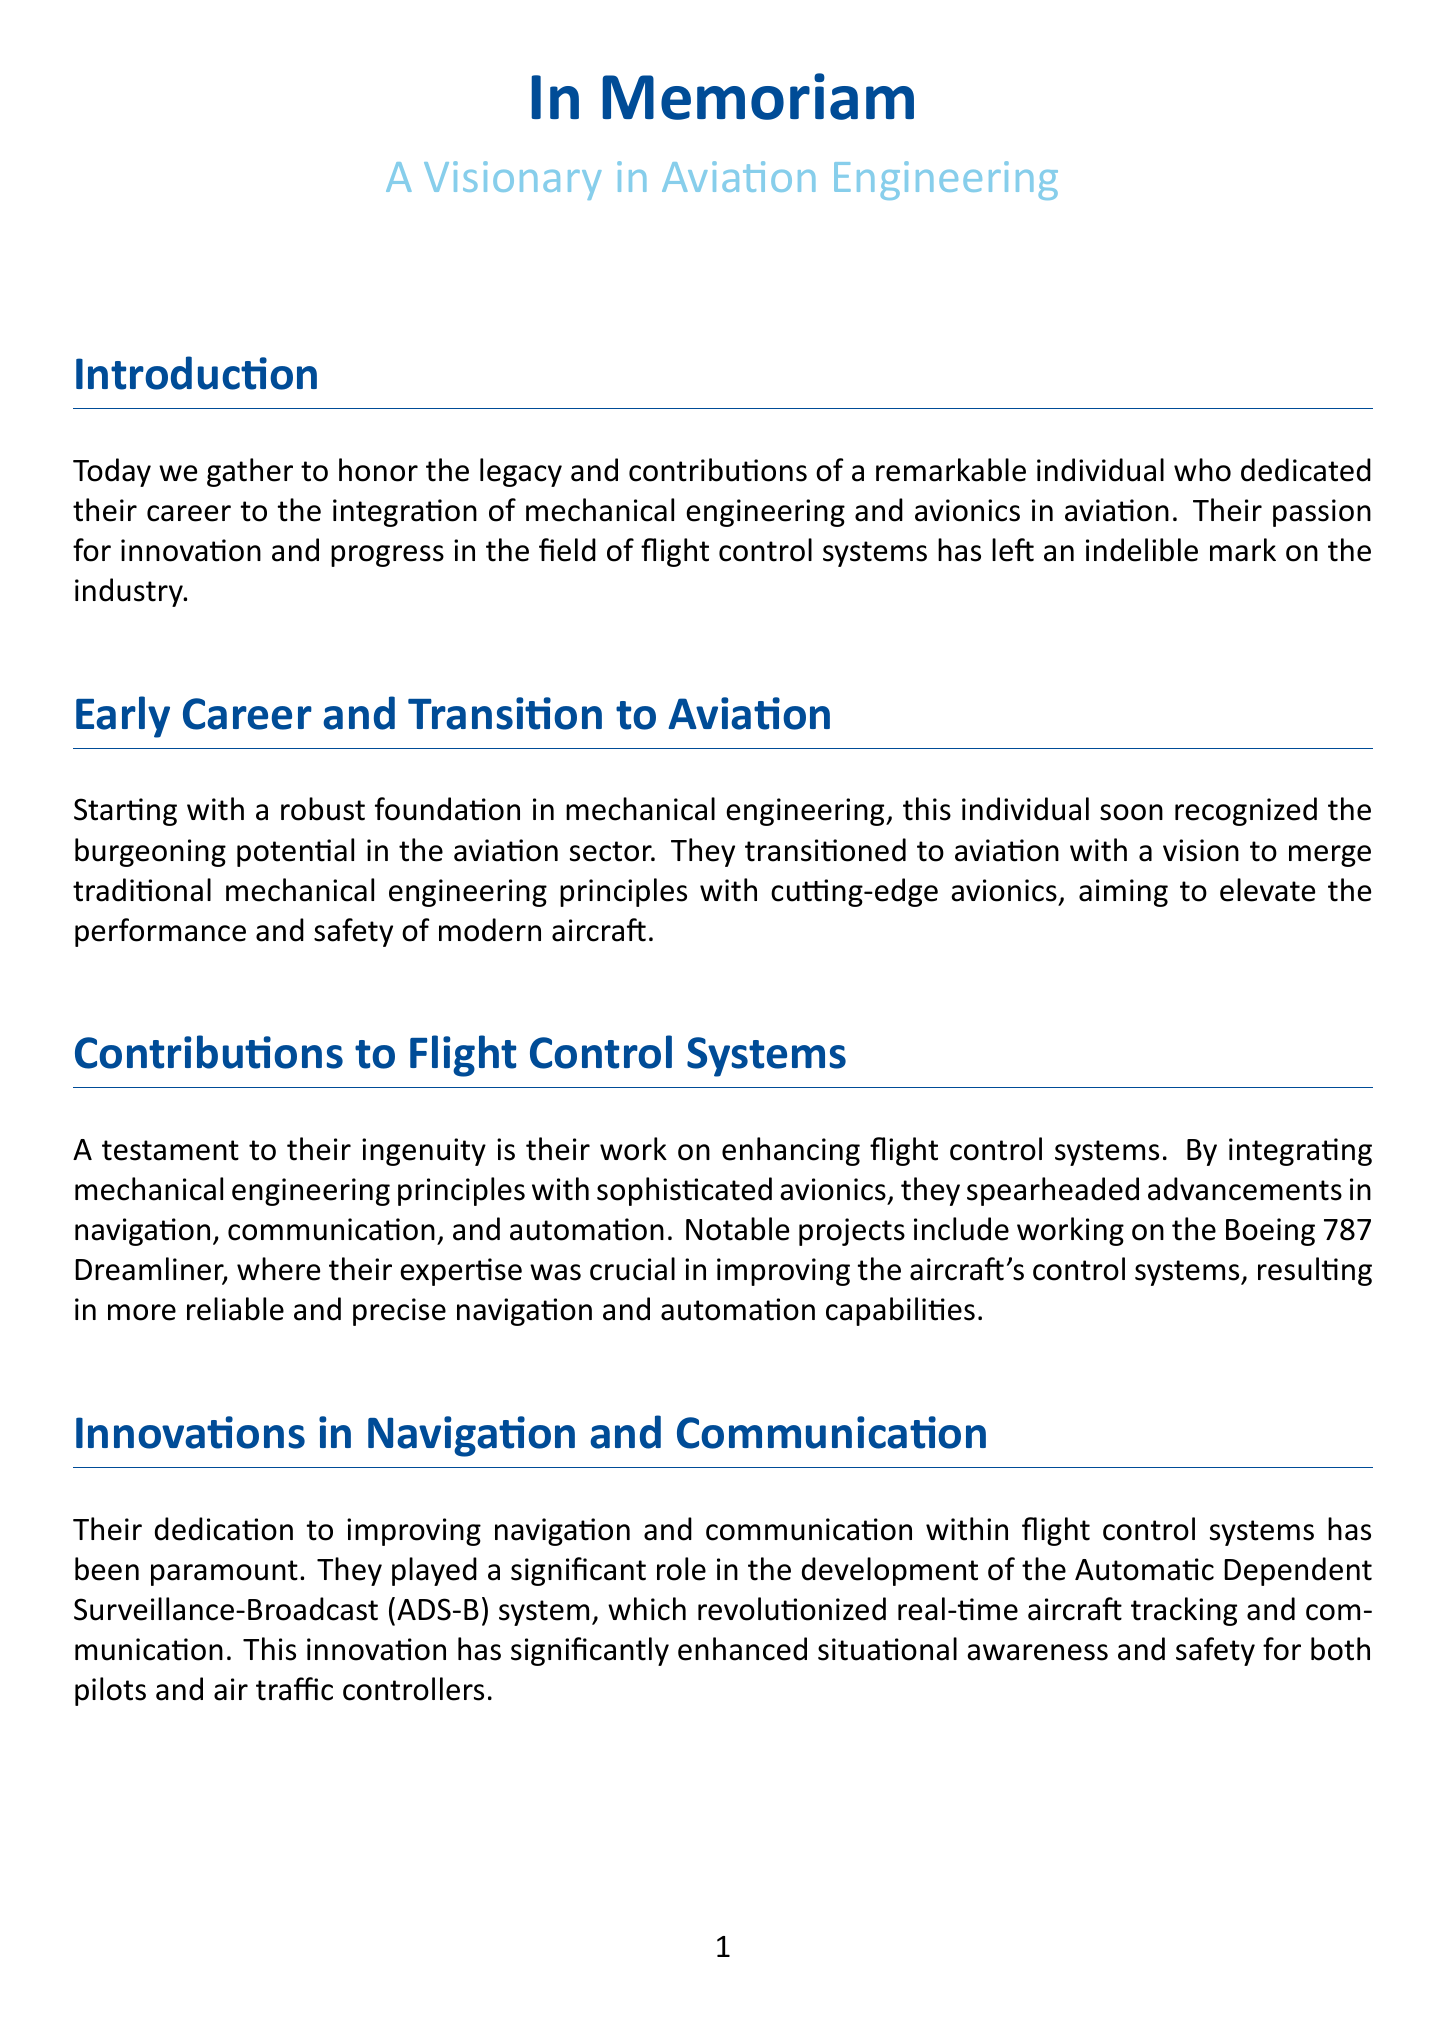What is the title of the eulogy? The title given in the document is "In Memoriam."
Answer: In Memoriam What is the individual's primary area of engineering? The document states that the individual had a foundation in mechanical engineering.
Answer: Mechanical engineering What aircraft was mentioned in relation to their work? The eulogy specifically highlights work on the Boeing 787 Dreamliner.
Answer: Boeing 787 Dreamliner What system revolutionized real-time aircraft tracking? The document indicates that the Automatic Dependent Surveillance-Broadcast (ADS-B) system was a significant development.
Answer: ADS-B What is one example of an advanced system integrated in commercial jets? The eulogy mentions the development of the Autoland system for Airbus A350 aircraft.
Answer: Autoland system How did the individual contribute to aviation safety? Their work allowed aircraft to land autonomously with remarkable accuracy, indicating their impact on safety enhancements.
Answer: Autonomously with remarkable accuracy What legacy is defined by the individual's work? The document describes their legacy as a relentless pursuit of excellence and a pioneering spirit.
Answer: Excellence and pioneering spirit What did the individual's contributions set new benchmarks for? Their contributions set new benchmarks for safety and efficiency in the aviation industry.
Answer: Safety and efficiency 